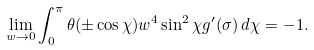<formula> <loc_0><loc_0><loc_500><loc_500>\lim _ { w \to 0 } \int _ { 0 } ^ { \pi } \theta ( \pm \cos \chi ) w ^ { 4 } \sin ^ { 2 } \chi g ^ { \prime } ( \sigma ) \, d \chi = - 1 .</formula> 